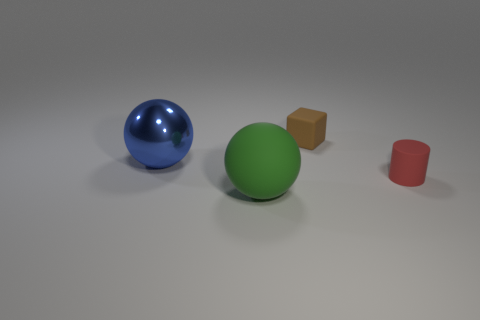Is there any other thing that is made of the same material as the blue thing?
Provide a succinct answer. No. Is the number of small brown things right of the cylinder less than the number of cubes that are right of the tiny rubber cube?
Keep it short and to the point. No. What number of cyan metallic cubes have the same size as the blue ball?
Keep it short and to the point. 0. Does the small thing behind the shiny thing have the same material as the big blue sphere?
Your response must be concise. No. Are there any things?
Offer a very short reply. Yes. What is the size of the red cylinder that is made of the same material as the block?
Offer a very short reply. Small. Is there a cyan sphere made of the same material as the tiny cylinder?
Offer a very short reply. No. The matte cylinder is what color?
Offer a very short reply. Red. What size is the matte thing that is left of the tiny thing that is behind the object that is right of the small brown rubber block?
Your answer should be compact. Large. How many other objects are the same shape as the blue thing?
Give a very brief answer. 1. 